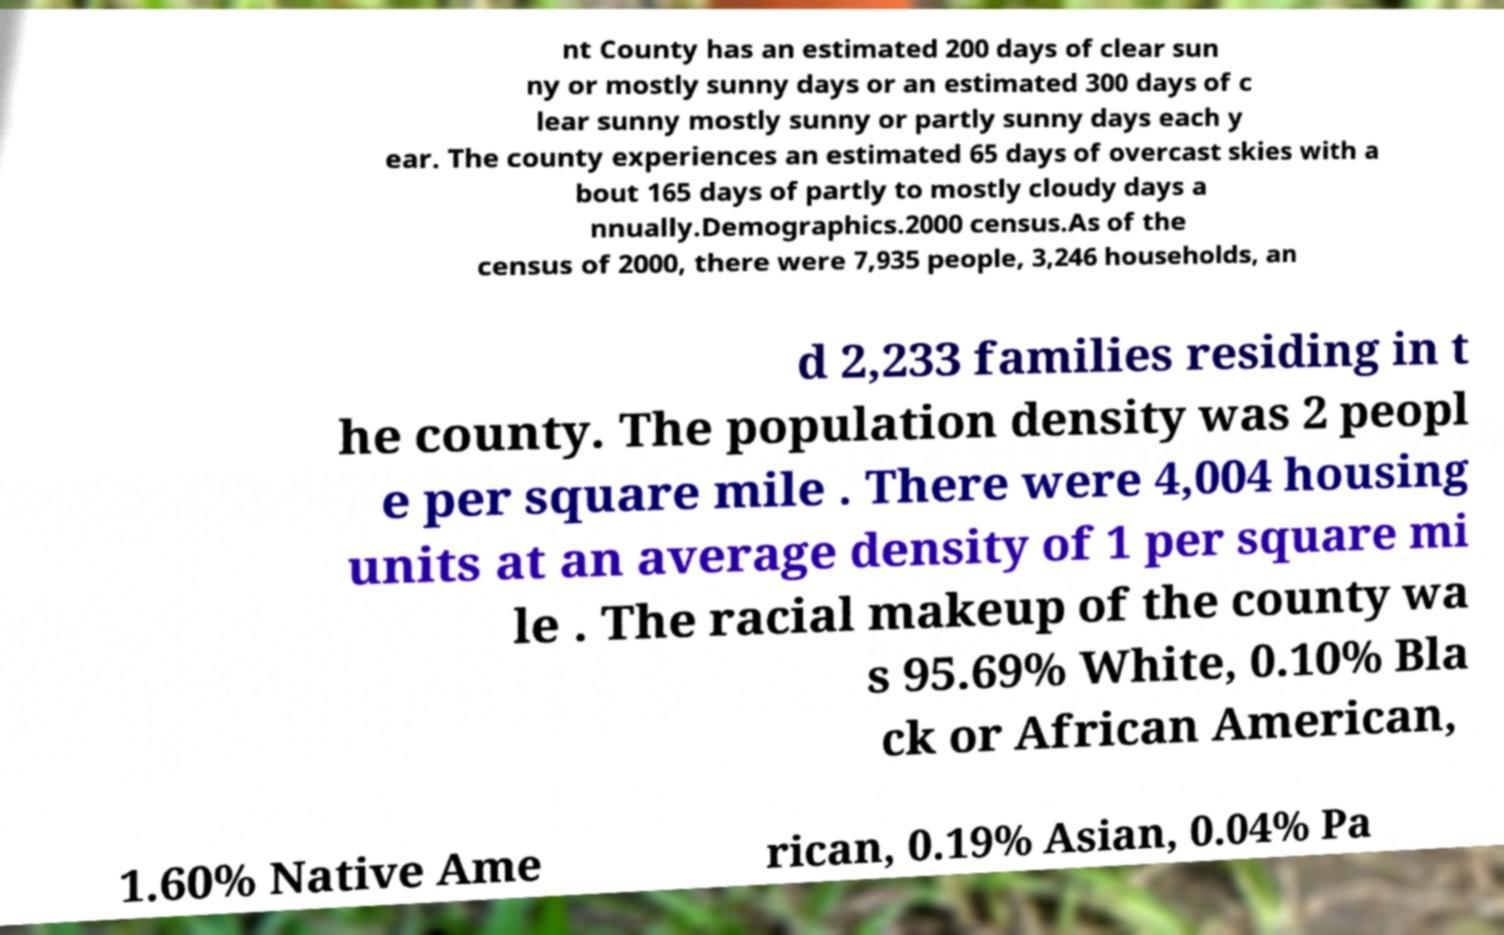I need the written content from this picture converted into text. Can you do that? nt County has an estimated 200 days of clear sun ny or mostly sunny days or an estimated 300 days of c lear sunny mostly sunny or partly sunny days each y ear. The county experiences an estimated 65 days of overcast skies with a bout 165 days of partly to mostly cloudy days a nnually.Demographics.2000 census.As of the census of 2000, there were 7,935 people, 3,246 households, an d 2,233 families residing in t he county. The population density was 2 peopl e per square mile . There were 4,004 housing units at an average density of 1 per square mi le . The racial makeup of the county wa s 95.69% White, 0.10% Bla ck or African American, 1.60% Native Ame rican, 0.19% Asian, 0.04% Pa 